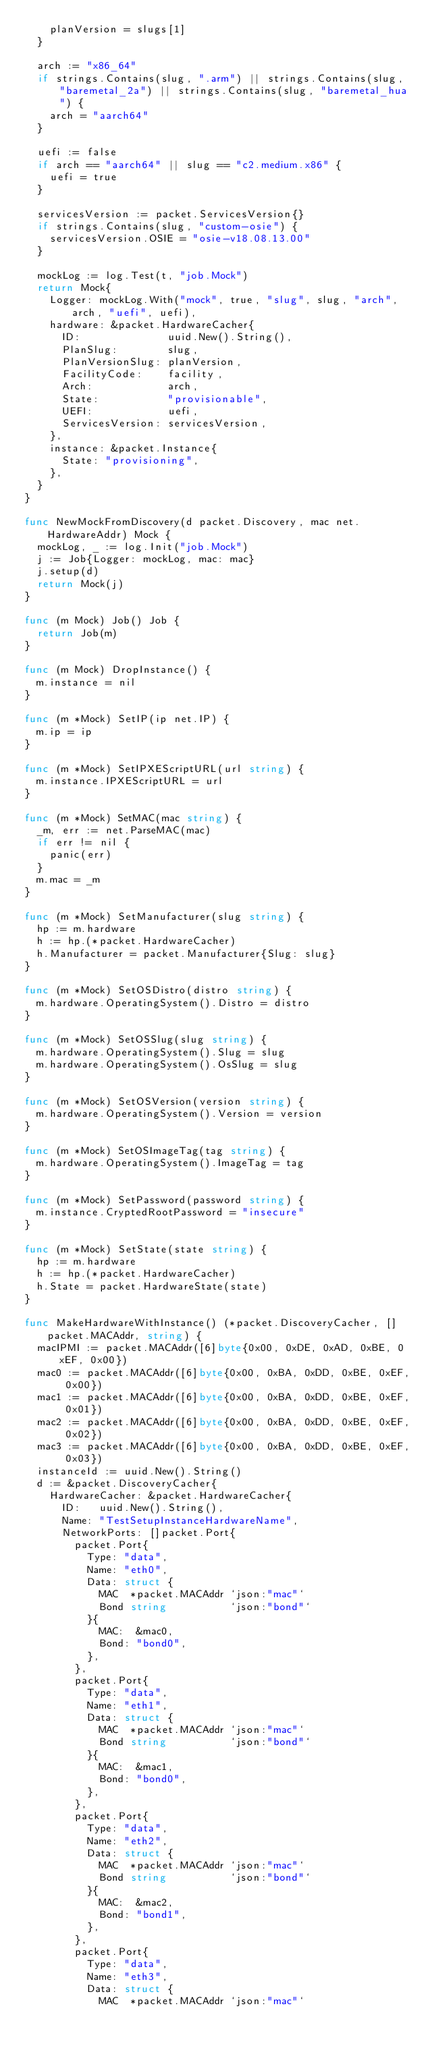Convert code to text. <code><loc_0><loc_0><loc_500><loc_500><_Go_>		planVersion = slugs[1]
	}

	arch := "x86_64"
	if strings.Contains(slug, ".arm") || strings.Contains(slug, "baremetal_2a") || strings.Contains(slug, "baremetal_hua") {
		arch = "aarch64"
	}

	uefi := false
	if arch == "aarch64" || slug == "c2.medium.x86" {
		uefi = true
	}

	servicesVersion := packet.ServicesVersion{}
	if strings.Contains(slug, "custom-osie") {
		servicesVersion.OSIE = "osie-v18.08.13.00"
	}

	mockLog := log.Test(t, "job.Mock")
	return Mock{
		Logger: mockLog.With("mock", true, "slug", slug, "arch", arch, "uefi", uefi),
		hardware: &packet.HardwareCacher{
			ID:              uuid.New().String(),
			PlanSlug:        slug,
			PlanVersionSlug: planVersion,
			FacilityCode:    facility,
			Arch:            arch,
			State:           "provisionable",
			UEFI:            uefi,
			ServicesVersion: servicesVersion,
		},
		instance: &packet.Instance{
			State: "provisioning",
		},
	}
}

func NewMockFromDiscovery(d packet.Discovery, mac net.HardwareAddr) Mock {
	mockLog, _ := log.Init("job.Mock")
	j := Job{Logger: mockLog, mac: mac}
	j.setup(d)
	return Mock(j)
}

func (m Mock) Job() Job {
	return Job(m)
}

func (m Mock) DropInstance() {
	m.instance = nil
}

func (m *Mock) SetIP(ip net.IP) {
	m.ip = ip
}

func (m *Mock) SetIPXEScriptURL(url string) {
	m.instance.IPXEScriptURL = url
}

func (m *Mock) SetMAC(mac string) {
	_m, err := net.ParseMAC(mac)
	if err != nil {
		panic(err)
	}
	m.mac = _m
}

func (m *Mock) SetManufacturer(slug string) {
	hp := m.hardware
	h := hp.(*packet.HardwareCacher)
	h.Manufacturer = packet.Manufacturer{Slug: slug}
}

func (m *Mock) SetOSDistro(distro string) {
	m.hardware.OperatingSystem().Distro = distro
}

func (m *Mock) SetOSSlug(slug string) {
	m.hardware.OperatingSystem().Slug = slug
	m.hardware.OperatingSystem().OsSlug = slug
}

func (m *Mock) SetOSVersion(version string) {
	m.hardware.OperatingSystem().Version = version
}

func (m *Mock) SetOSImageTag(tag string) {
	m.hardware.OperatingSystem().ImageTag = tag
}

func (m *Mock) SetPassword(password string) {
	m.instance.CryptedRootPassword = "insecure"
}

func (m *Mock) SetState(state string) {
	hp := m.hardware
	h := hp.(*packet.HardwareCacher)
	h.State = packet.HardwareState(state)
}

func MakeHardwareWithInstance() (*packet.DiscoveryCacher, []packet.MACAddr, string) {
	macIPMI := packet.MACAddr([6]byte{0x00, 0xDE, 0xAD, 0xBE, 0xEF, 0x00})
	mac0 := packet.MACAddr([6]byte{0x00, 0xBA, 0xDD, 0xBE, 0xEF, 0x00})
	mac1 := packet.MACAddr([6]byte{0x00, 0xBA, 0xDD, 0xBE, 0xEF, 0x01})
	mac2 := packet.MACAddr([6]byte{0x00, 0xBA, 0xDD, 0xBE, 0xEF, 0x02})
	mac3 := packet.MACAddr([6]byte{0x00, 0xBA, 0xDD, 0xBE, 0xEF, 0x03})
	instanceId := uuid.New().String()
	d := &packet.DiscoveryCacher{
		HardwareCacher: &packet.HardwareCacher{
			ID:   uuid.New().String(),
			Name: "TestSetupInstanceHardwareName",
			NetworkPorts: []packet.Port{
				packet.Port{
					Type: "data",
					Name: "eth0",
					Data: struct {
						MAC  *packet.MACAddr `json:"mac"`
						Bond string          `json:"bond"`
					}{
						MAC:  &mac0,
						Bond: "bond0",
					},
				},
				packet.Port{
					Type: "data",
					Name: "eth1",
					Data: struct {
						MAC  *packet.MACAddr `json:"mac"`
						Bond string          `json:"bond"`
					}{
						MAC:  &mac1,
						Bond: "bond0",
					},
				},
				packet.Port{
					Type: "data",
					Name: "eth2",
					Data: struct {
						MAC  *packet.MACAddr `json:"mac"`
						Bond string          `json:"bond"`
					}{
						MAC:  &mac2,
						Bond: "bond1",
					},
				},
				packet.Port{
					Type: "data",
					Name: "eth3",
					Data: struct {
						MAC  *packet.MACAddr `json:"mac"`</code> 